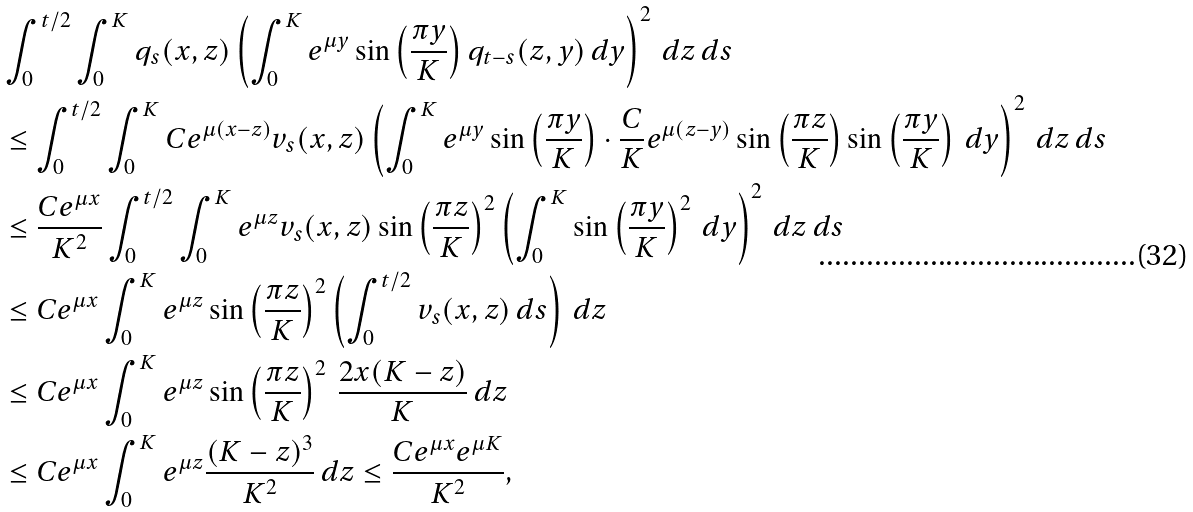<formula> <loc_0><loc_0><loc_500><loc_500>& \int _ { 0 } ^ { t / 2 } \int _ { 0 } ^ { K } q _ { s } ( x , z ) \left ( \int _ { 0 } ^ { K } e ^ { \mu y } \sin \left ( \frac { \pi y } { K } \right ) q _ { t - s } ( z , y ) \, d y \right ) ^ { 2 } \, d z \, d s \\ & \leq \int _ { 0 } ^ { t / 2 } \int _ { 0 } ^ { K } C e ^ { \mu ( x - z ) } v _ { s } ( x , z ) \left ( \int _ { 0 } ^ { K } e ^ { \mu y } \sin \left ( \frac { \pi y } { K } \right ) \cdot \frac { C } { K } e ^ { \mu ( z - y ) } \sin \left ( \frac { \pi z } { K } \right ) \sin \left ( \frac { \pi y } { K } \right ) \, d y \right ) ^ { 2 } \, d z \, d s \\ & \leq \frac { C e ^ { \mu x } } { K ^ { 2 } } \int _ { 0 } ^ { t / 2 } \int _ { 0 } ^ { K } e ^ { \mu z } v _ { s } ( x , z ) \sin \left ( \frac { \pi z } { K } \right ) ^ { 2 } \left ( \int _ { 0 } ^ { K } \sin \left ( \frac { \pi y } { K } \right ) ^ { 2 } \, d y \right ) ^ { 2 } \, d z \, d s \\ & \leq C e ^ { \mu x } \int _ { 0 } ^ { K } e ^ { \mu z } \sin \left ( \frac { \pi z } { K } \right ) ^ { 2 } \left ( \int _ { 0 } ^ { t / 2 } v _ { s } ( x , z ) \, d s \right ) \, d z \\ & \leq C e ^ { \mu x } \int _ { 0 } ^ { K } e ^ { \mu z } \sin \left ( \frac { \pi z } { K } \right ) ^ { 2 } \, \frac { 2 x ( K - z ) } { K } \, d z \\ & \leq C e ^ { \mu x } \int _ { 0 } ^ { K } e ^ { \mu z } \frac { ( K - z ) ^ { 3 } } { K ^ { 2 } } \, d z \leq \frac { C e ^ { \mu x } e ^ { \mu K } } { K ^ { 2 } } ,</formula> 